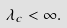<formula> <loc_0><loc_0><loc_500><loc_500>\lambda _ { c } < \infty .</formula> 